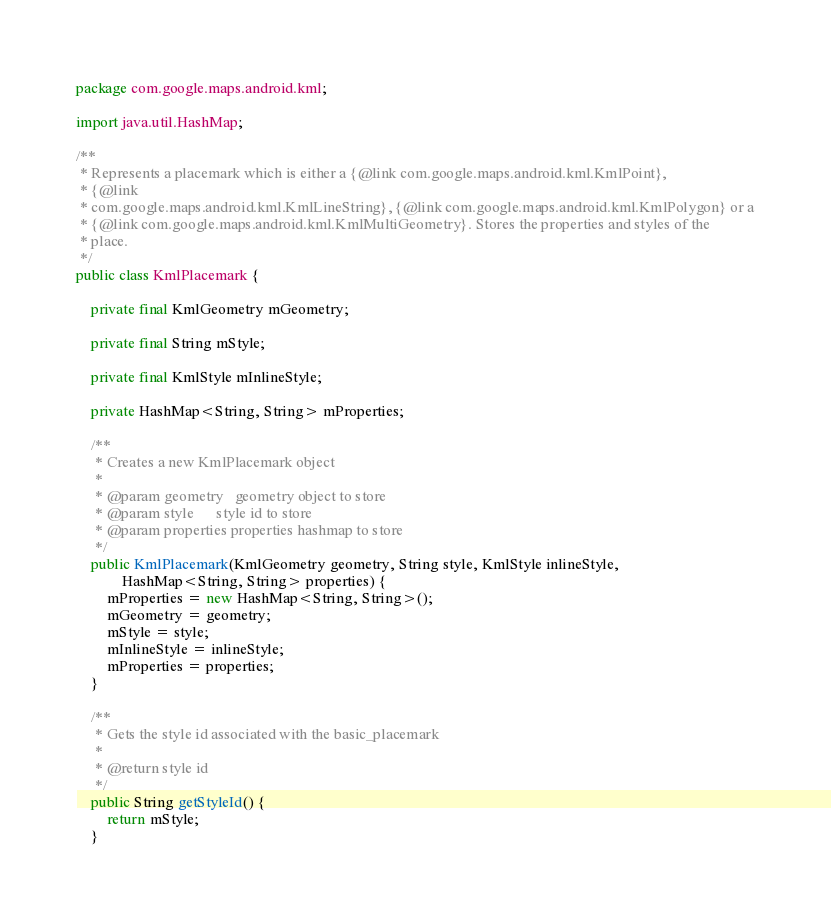Convert code to text. <code><loc_0><loc_0><loc_500><loc_500><_Java_>package com.google.maps.android.kml;

import java.util.HashMap;

/**
 * Represents a placemark which is either a {@link com.google.maps.android.kml.KmlPoint},
 * {@link
 * com.google.maps.android.kml.KmlLineString}, {@link com.google.maps.android.kml.KmlPolygon} or a
 * {@link com.google.maps.android.kml.KmlMultiGeometry}. Stores the properties and styles of the
 * place.
 */
public class KmlPlacemark {

    private final KmlGeometry mGeometry;

    private final String mStyle;

    private final KmlStyle mInlineStyle;

    private HashMap<String, String> mProperties;

    /**
     * Creates a new KmlPlacemark object
     *
     * @param geometry   geometry object to store
     * @param style      style id to store
     * @param properties properties hashmap to store
     */
    public KmlPlacemark(KmlGeometry geometry, String style, KmlStyle inlineStyle,
            HashMap<String, String> properties) {
        mProperties = new HashMap<String, String>();
        mGeometry = geometry;
        mStyle = style;
        mInlineStyle = inlineStyle;
        mProperties = properties;
    }

    /**
     * Gets the style id associated with the basic_placemark
     *
     * @return style id
     */
    public String getStyleId() {
        return mStyle;
    }
</code> 